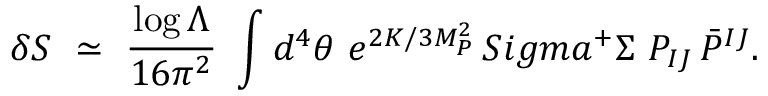Convert formula to latex. <formula><loc_0><loc_0><loc_500><loc_500>\delta S \ \simeq \ { \frac { \log \Lambda } { 1 6 \pi ^ { 2 } } } \ \int d ^ { 4 } \theta \ e ^ { 2 K / 3 M _ { P } ^ { 2 } } \, S i g m a ^ { + } \Sigma \ P _ { I J } \, \bar { P } ^ { I J } .</formula> 